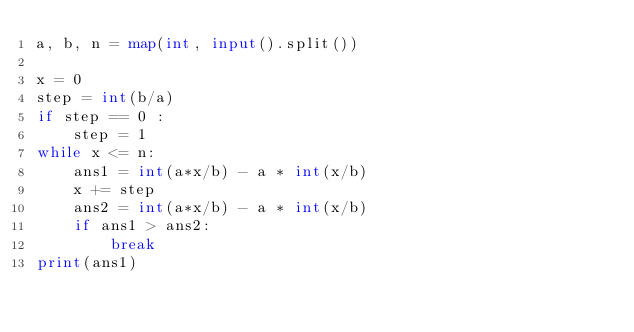<code> <loc_0><loc_0><loc_500><loc_500><_Python_>a, b, n = map(int, input().split())

x = 0
step = int(b/a)
if step == 0 :
    step = 1
while x <= n:
    ans1 = int(a*x/b) - a * int(x/b)
    x += step
    ans2 = int(a*x/b) - a * int(x/b)
    if ans1 > ans2:
        break
print(ans1)
</code> 